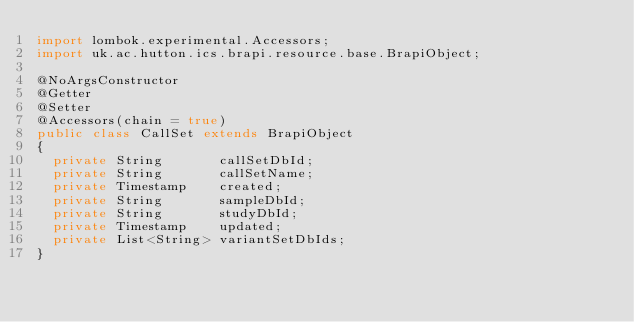<code> <loc_0><loc_0><loc_500><loc_500><_Java_>import lombok.experimental.Accessors;
import uk.ac.hutton.ics.brapi.resource.base.BrapiObject;

@NoArgsConstructor
@Getter
@Setter
@Accessors(chain = true)
public class CallSet extends BrapiObject
{
	private String       callSetDbId;
	private String       callSetName;
	private Timestamp    created;
	private String       sampleDbId;
	private String       studyDbId;
	private Timestamp    updated;
	private List<String> variantSetDbIds;
}
</code> 